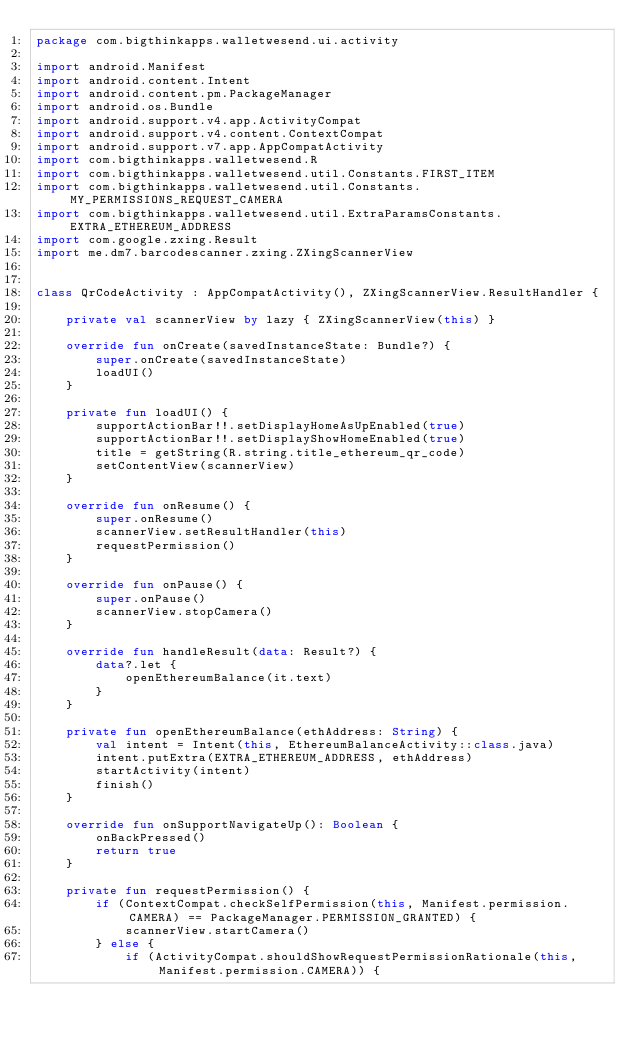Convert code to text. <code><loc_0><loc_0><loc_500><loc_500><_Kotlin_>package com.bigthinkapps.walletwesend.ui.activity

import android.Manifest
import android.content.Intent
import android.content.pm.PackageManager
import android.os.Bundle
import android.support.v4.app.ActivityCompat
import android.support.v4.content.ContextCompat
import android.support.v7.app.AppCompatActivity
import com.bigthinkapps.walletwesend.R
import com.bigthinkapps.walletwesend.util.Constants.FIRST_ITEM
import com.bigthinkapps.walletwesend.util.Constants.MY_PERMISSIONS_REQUEST_CAMERA
import com.bigthinkapps.walletwesend.util.ExtraParamsConstants.EXTRA_ETHEREUM_ADDRESS
import com.google.zxing.Result
import me.dm7.barcodescanner.zxing.ZXingScannerView


class QrCodeActivity : AppCompatActivity(), ZXingScannerView.ResultHandler {

    private val scannerView by lazy { ZXingScannerView(this) }

    override fun onCreate(savedInstanceState: Bundle?) {
        super.onCreate(savedInstanceState)
        loadUI()
    }

    private fun loadUI() {
        supportActionBar!!.setDisplayHomeAsUpEnabled(true)
        supportActionBar!!.setDisplayShowHomeEnabled(true)
        title = getString(R.string.title_ethereum_qr_code)
        setContentView(scannerView)
    }

    override fun onResume() {
        super.onResume()
        scannerView.setResultHandler(this)
        requestPermission()
    }

    override fun onPause() {
        super.onPause()
        scannerView.stopCamera()
    }

    override fun handleResult(data: Result?) {
        data?.let {
            openEthereumBalance(it.text)
        }
    }

    private fun openEthereumBalance(ethAddress: String) {
        val intent = Intent(this, EthereumBalanceActivity::class.java)
        intent.putExtra(EXTRA_ETHEREUM_ADDRESS, ethAddress)
        startActivity(intent)
        finish()
    }

    override fun onSupportNavigateUp(): Boolean {
        onBackPressed()
        return true
    }

    private fun requestPermission() {
        if (ContextCompat.checkSelfPermission(this, Manifest.permission.CAMERA) == PackageManager.PERMISSION_GRANTED) {
            scannerView.startCamera()
        } else {
            if (ActivityCompat.shouldShowRequestPermissionRationale(this, Manifest.permission.CAMERA)) {</code> 